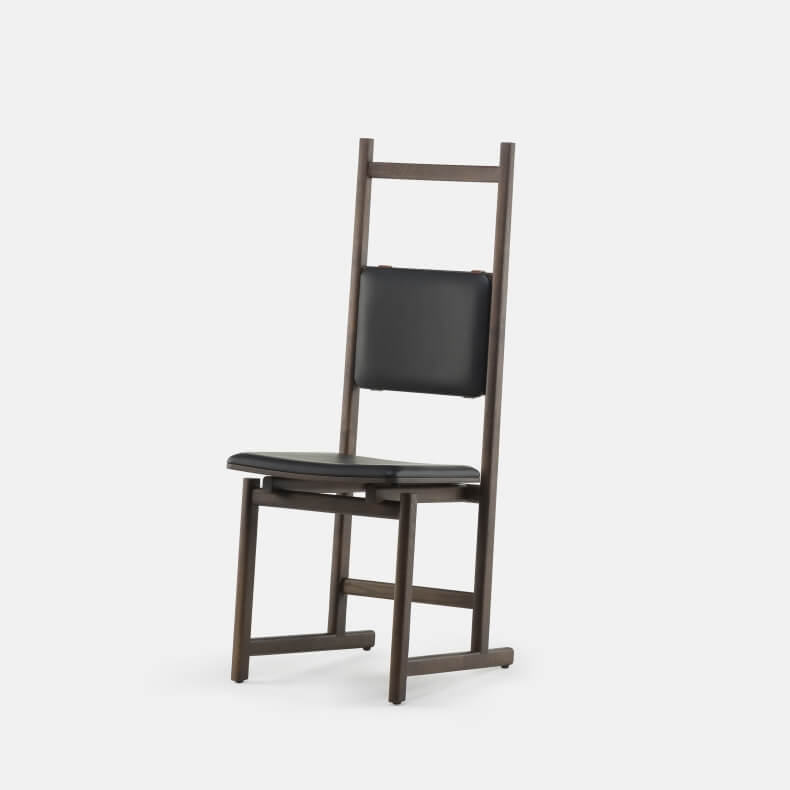What type of setting or environment might this chair be best suited for based on its design and the materials visible in the image? The chair's minimalist and sleek design, with clean lines and a lack of ornate details, makes it ideal for modern and contemporary settings. The dark frame and black upholstery suggest that it could fit perfectly in a professional environment like an office, conference room, or a modern home's dining area. Additionally, the ergonomic curve of the backrest indicates a design focused on comfort and support, making it suitable for settings where extended sitting is common, such as workspaces or study areas. The materials convey a sense of durability and elegance, enhancing its suitability for both formal and informal environments. 